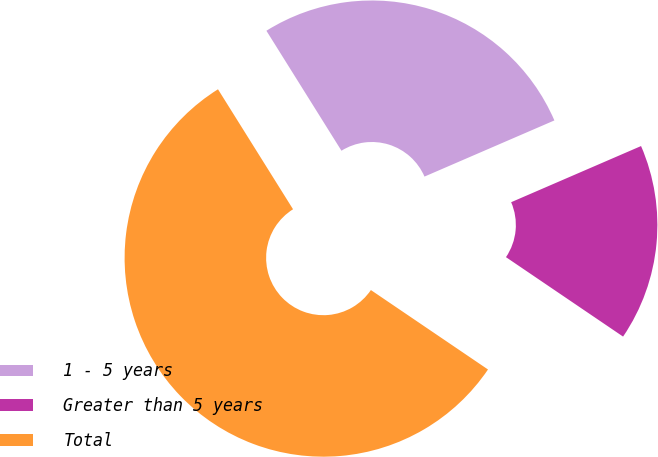Convert chart. <chart><loc_0><loc_0><loc_500><loc_500><pie_chart><fcel>1 - 5 years<fcel>Greater than 5 years<fcel>Total<nl><fcel>27.4%<fcel>15.98%<fcel>56.61%<nl></chart> 